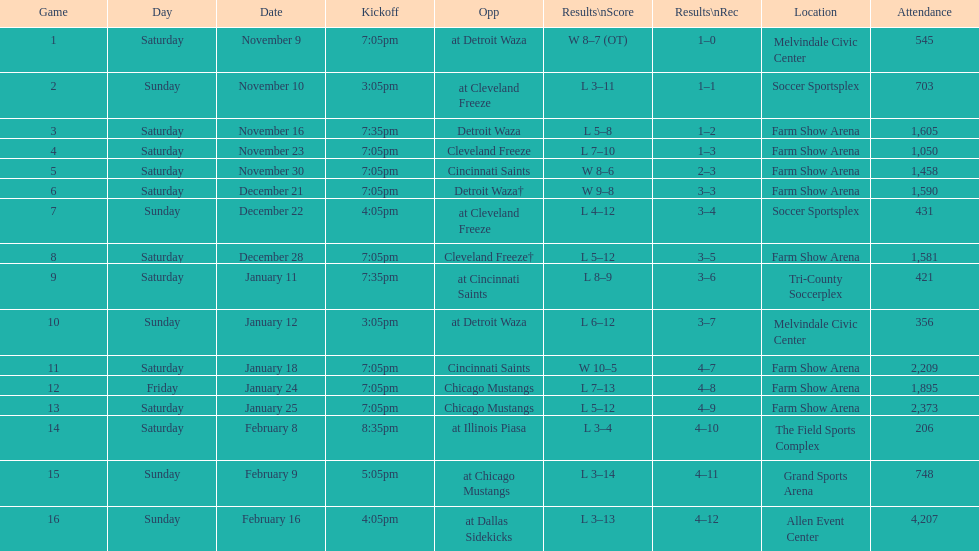Which opponent is listed after cleveland freeze in the table? Detroit Waza. 